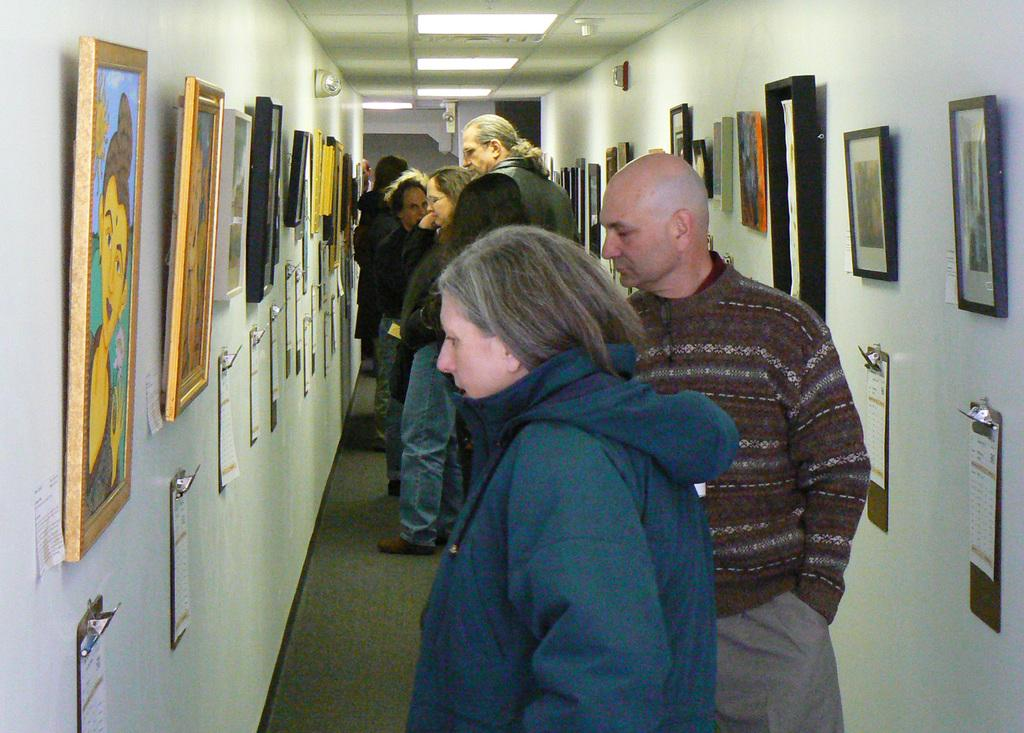What are the people in the image doing? The people in the image are standing on the floor. What can be seen on the walls in the image? There are frames, posters, and clipboards on the walls. What is visible at the top of the image? There are lights and a ceiling visible at the top of the image. What type of rhythm can be heard coming from the division in the image? There is no division or rhythm present in the image; it features people standing on the floor and various items on the walls. 